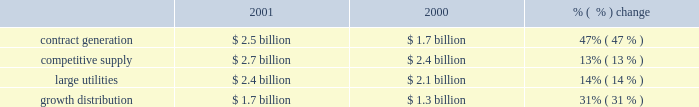Future impairments would be recorded in income from continuing operations .
The statement provides specific guidance for testing goodwill for impairment .
The company had $ 3.2 billion of goodwill at december 31 , 2001 .
Goodwill amortization was $ 62 million for the year ended december 31 , 2001 .
The company is currently assessing the impact of sfas no .
142 on its financial position and results of operations .
In june 2001 , the fasb issued sfas no .
143 , 2018 2018accounting for asset retirement obligations , 2019 2019 which addresses financial accounting and reporting for obligations associated with the retirement of tangible long-lived assets and the associated asset retirement costs .
This statement is effective for financial statements issued for fiscal years beginning after june 15 , 2002 .
The statement requires recognition of legal obligations associated with the retirement of a long-lived asset , except for certain obligations of lessees .
The company is currently assessing the impact of sfas no .
143 on its financial position and results of operations .
In december 2001 , the fasb revised its earlier conclusion , derivatives implementation group ( 2018 2018dig 2019 2019 ) issue c-15 , related to contracts involving the purchase or sale of electricity .
Contracts for the purchase or sale of electricity , both forward and option contracts , including capacity contracts , may qualify for the normal purchases and sales exemption and are not required to be accounted for as derivatives under sfas no .
133 .
In order for contracts to qualify for this exemption , they must meet certain criteria , which include the requirement for physical delivery of the electricity to be purchased or sold under the contract only in the normal course of business .
Additionally , contracts that have a price based on an underlying that is not clearly and closely related to the electricity being sold or purchased or that are denominated in a currency that is foreign to the buyer or seller are not considered normal purchases and normal sales and are required to be accounted for as derivatives under sfas no .
133 .
This revised conclusion is effective beginning april 1 , 2002 .
The company is currently assessing the impact of revised dig issue c-15 on its financial condition and results of operations .
2001 compared to 2000 revenues revenues increased $ 1.8 billion , or 24% ( 24 % ) to $ 9.3 billion in 2001 from $ 7.5 billion in 2000 .
The increase in revenues is due to the acquisition of new businesses , new operations from greenfield projects and positive improvements from existing operations .
Excluding businesses acquired or that commenced commercial operations in 2001 or 2000 , revenues increased 5% ( 5 % ) to $ 7.1 billion in 2001 .
The table shows the revenue of each segment: .
Contract generation revenues increased $ 800 million , or 47% ( 47 % ) to $ 2.5 billion in 2001 from $ 1.7 billion in 2000 , principally resulting from the addition of revenues attributable to businesses acquired during 2001 or 2000 .
Excluding businesses acquired or that commenced commercial operations in 2001 or 2000 , contract generation revenues increased 2% ( 2 % ) to $ 1.7 billion in 2001 .
The increase in contract generation segment revenues was due primarily to increases in south america , europe/africa and asia .
In south america , contract generation segment revenues increased $ 472 million due mainly to the acquisition of gener and the full year of operations at uruguaiana offset by reduced revenues at tiete from the electricity rationing in brazil .
In europe/africa , contract generation segment revenues increased $ 88 million , and the acquisition of a controlling interest in kilroot during 2000 was the largest contributor to the increase .
In asia , contract generation segment revenues increased $ 96 million , and increased operations from our ecogen peaking plant was the most significant contributor to the .
Based on the current amount of annual amortization , how many years will it take to fully amortize the goodwill balance at december 31 , 2001? 
Computations: ((3.2 * 1000) / 62)
Answer: 51.6129. 